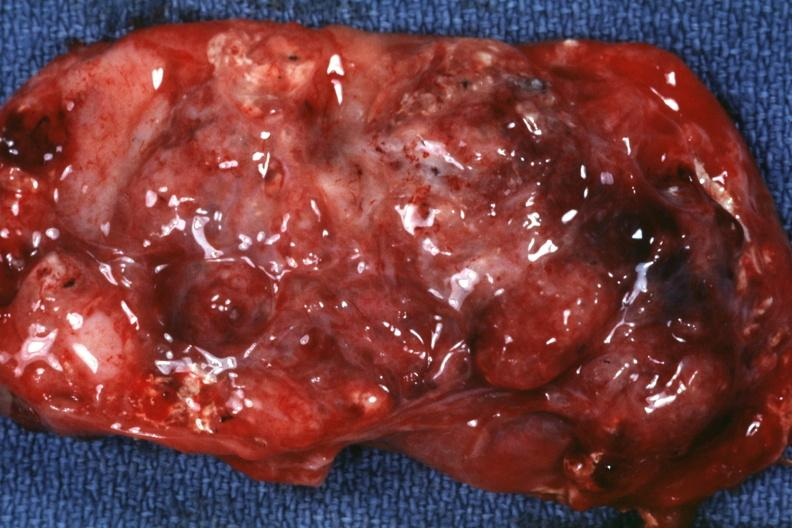does carcinomatosis endometrium primary show excised tumor mass?
Answer the question using a single word or phrase. No 